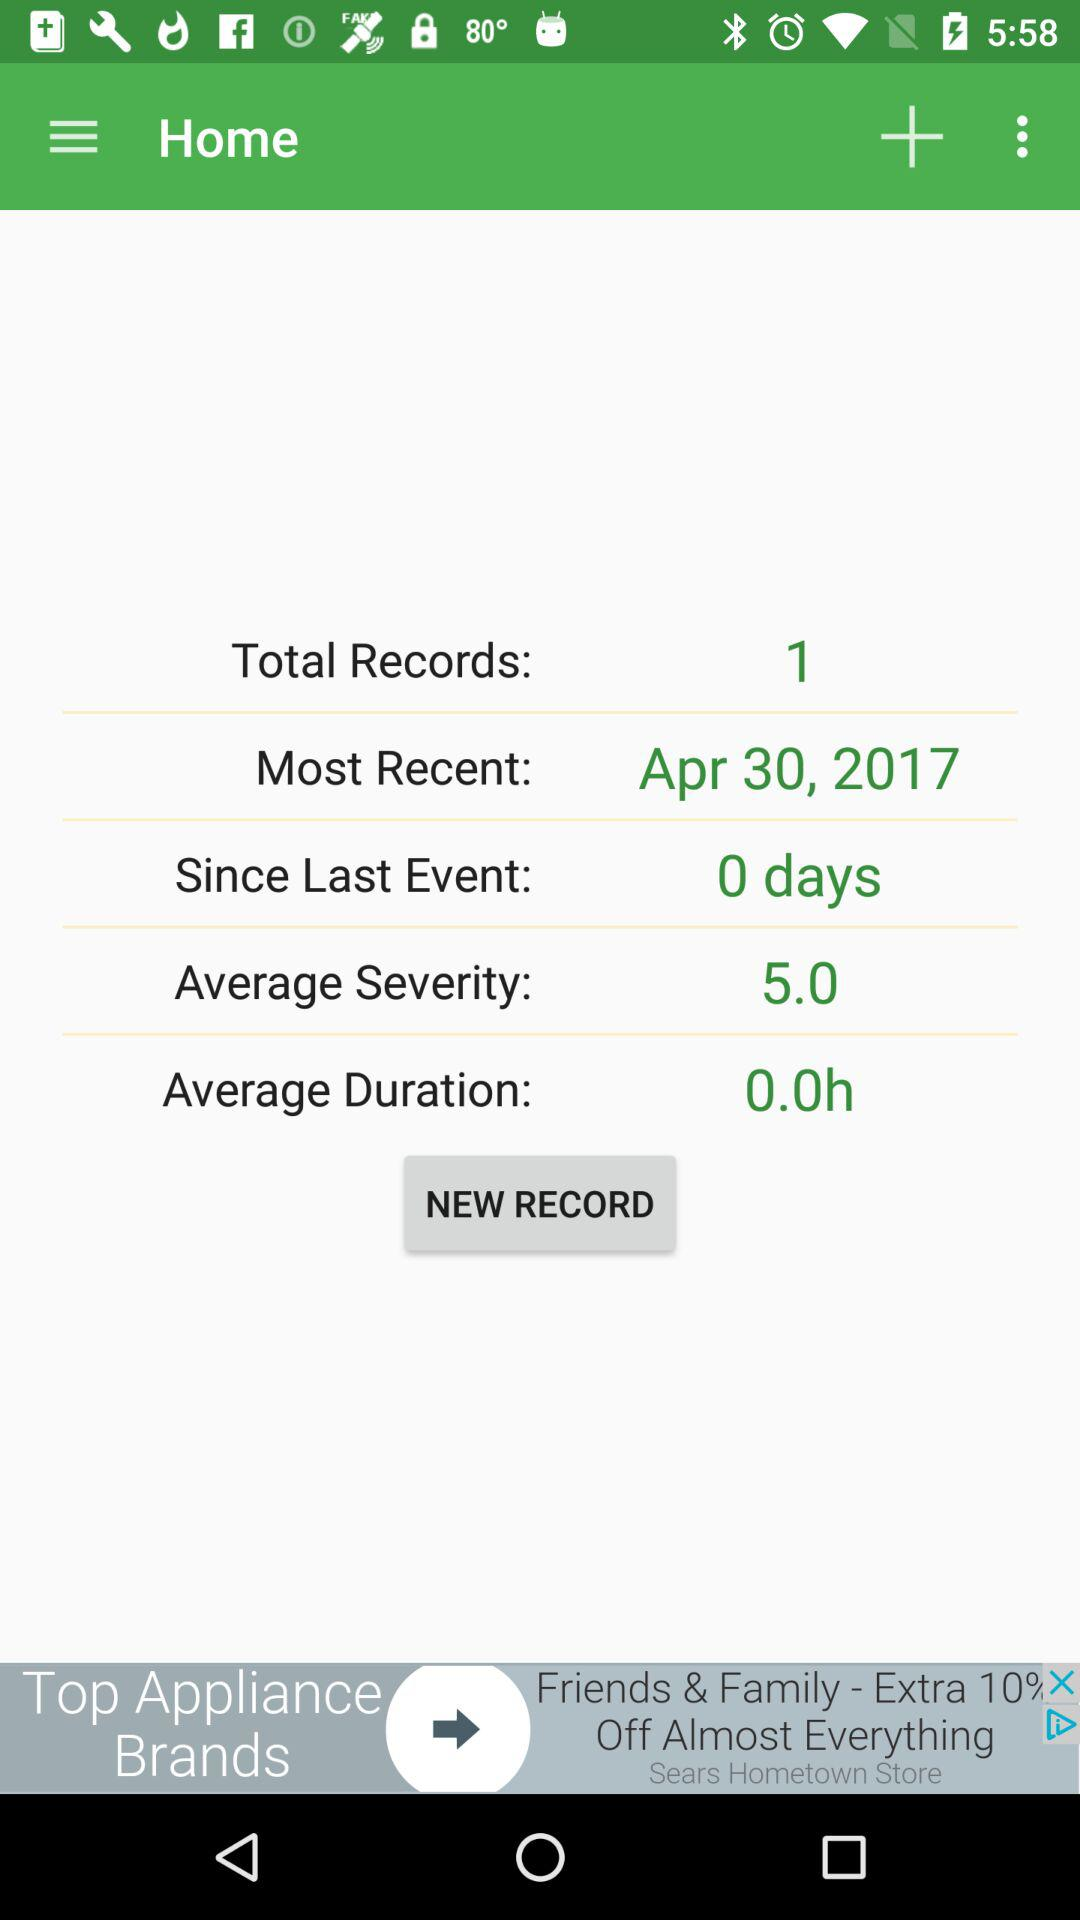What is the average severity of the event? The average severity of the event is 5. 